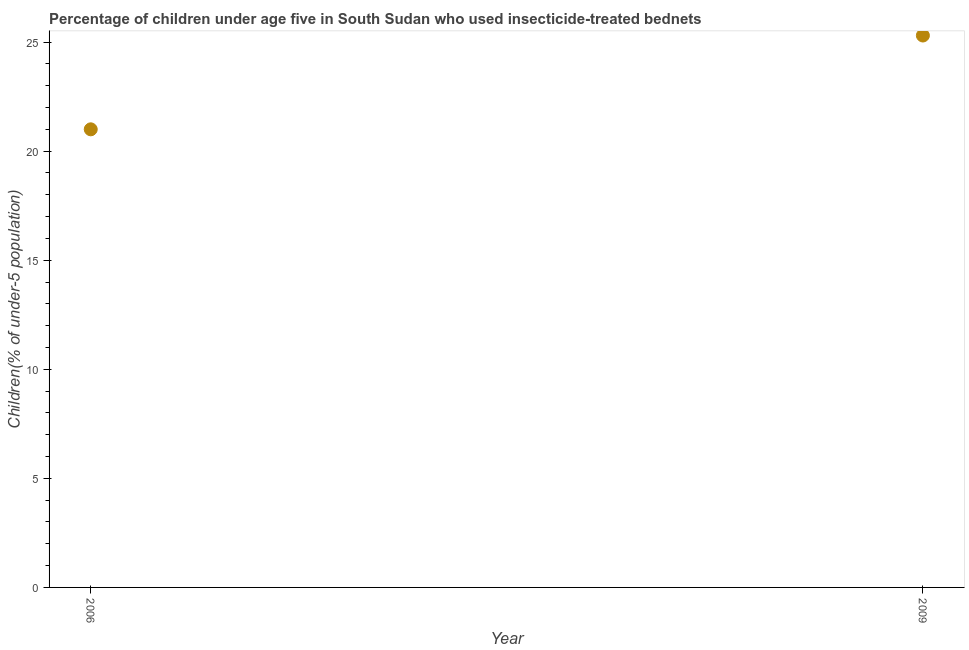What is the percentage of children who use of insecticide-treated bed nets in 2009?
Keep it short and to the point. 25.3. Across all years, what is the maximum percentage of children who use of insecticide-treated bed nets?
Provide a short and direct response. 25.3. Across all years, what is the minimum percentage of children who use of insecticide-treated bed nets?
Offer a terse response. 21. In which year was the percentage of children who use of insecticide-treated bed nets maximum?
Provide a succinct answer. 2009. In which year was the percentage of children who use of insecticide-treated bed nets minimum?
Provide a succinct answer. 2006. What is the sum of the percentage of children who use of insecticide-treated bed nets?
Offer a very short reply. 46.3. What is the difference between the percentage of children who use of insecticide-treated bed nets in 2006 and 2009?
Your response must be concise. -4.3. What is the average percentage of children who use of insecticide-treated bed nets per year?
Your answer should be very brief. 23.15. What is the median percentage of children who use of insecticide-treated bed nets?
Give a very brief answer. 23.15. In how many years, is the percentage of children who use of insecticide-treated bed nets greater than 10 %?
Your answer should be compact. 2. What is the ratio of the percentage of children who use of insecticide-treated bed nets in 2006 to that in 2009?
Provide a succinct answer. 0.83. Is the percentage of children who use of insecticide-treated bed nets in 2006 less than that in 2009?
Make the answer very short. Yes. In how many years, is the percentage of children who use of insecticide-treated bed nets greater than the average percentage of children who use of insecticide-treated bed nets taken over all years?
Provide a short and direct response. 1. Does the percentage of children who use of insecticide-treated bed nets monotonically increase over the years?
Your answer should be compact. Yes. Are the values on the major ticks of Y-axis written in scientific E-notation?
Keep it short and to the point. No. Does the graph contain grids?
Provide a succinct answer. No. What is the title of the graph?
Provide a succinct answer. Percentage of children under age five in South Sudan who used insecticide-treated bednets. What is the label or title of the Y-axis?
Your response must be concise. Children(% of under-5 population). What is the Children(% of under-5 population) in 2006?
Ensure brevity in your answer.  21. What is the Children(% of under-5 population) in 2009?
Your answer should be compact. 25.3. What is the ratio of the Children(% of under-5 population) in 2006 to that in 2009?
Offer a terse response. 0.83. 